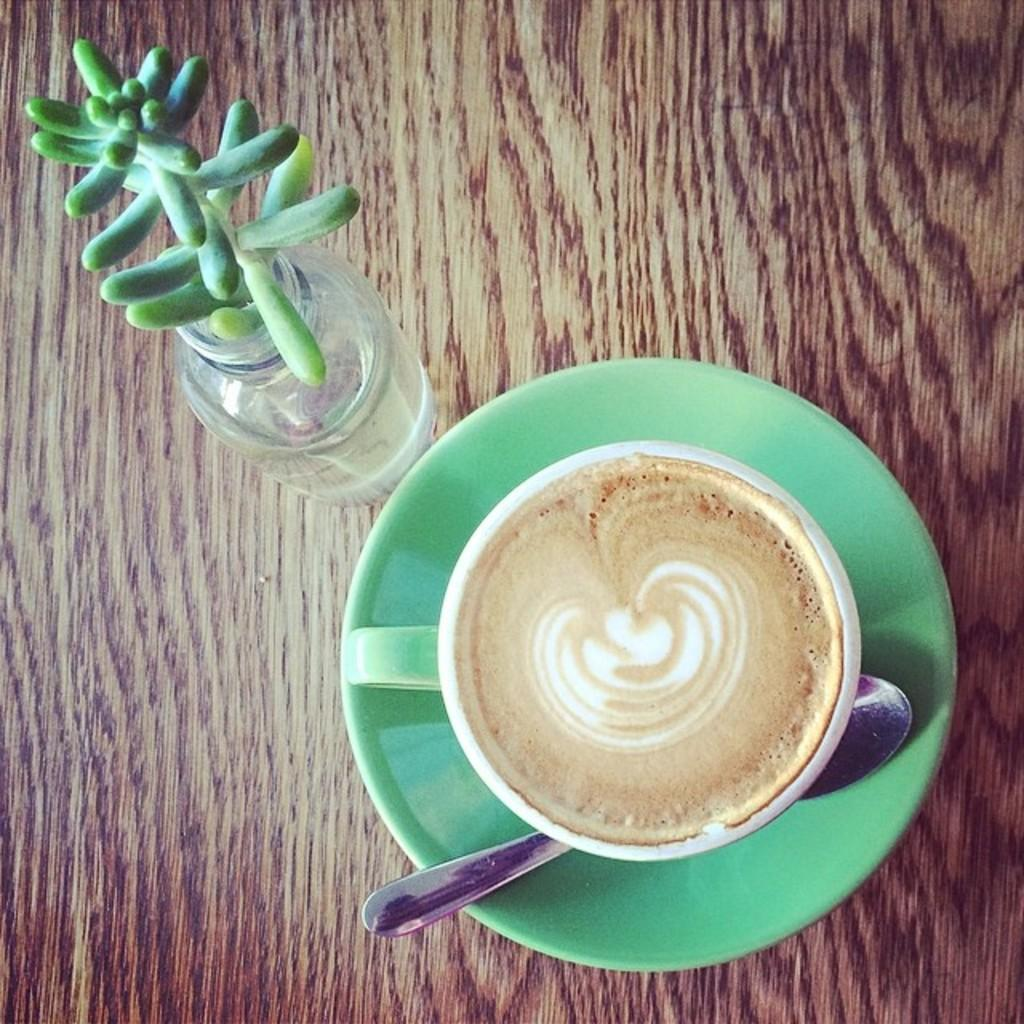What is on the table in the image? There is a coffee cup on a saucer, a spoon, and a plant on the table in the image. What might be used for stirring or scooping in the image? There is a spoon in the image that can be used for stirring or scooping. What type of plant is on the table in the image? The type of plant cannot be determined from the image. What sense is being stimulated by the heat in the image? There is no heat present in the image, so no sense is being stimulated by it. What type of stem is holding the coffee cup in the image? There is no stem holding the coffee cup in the image; it is resting on a saucer. 